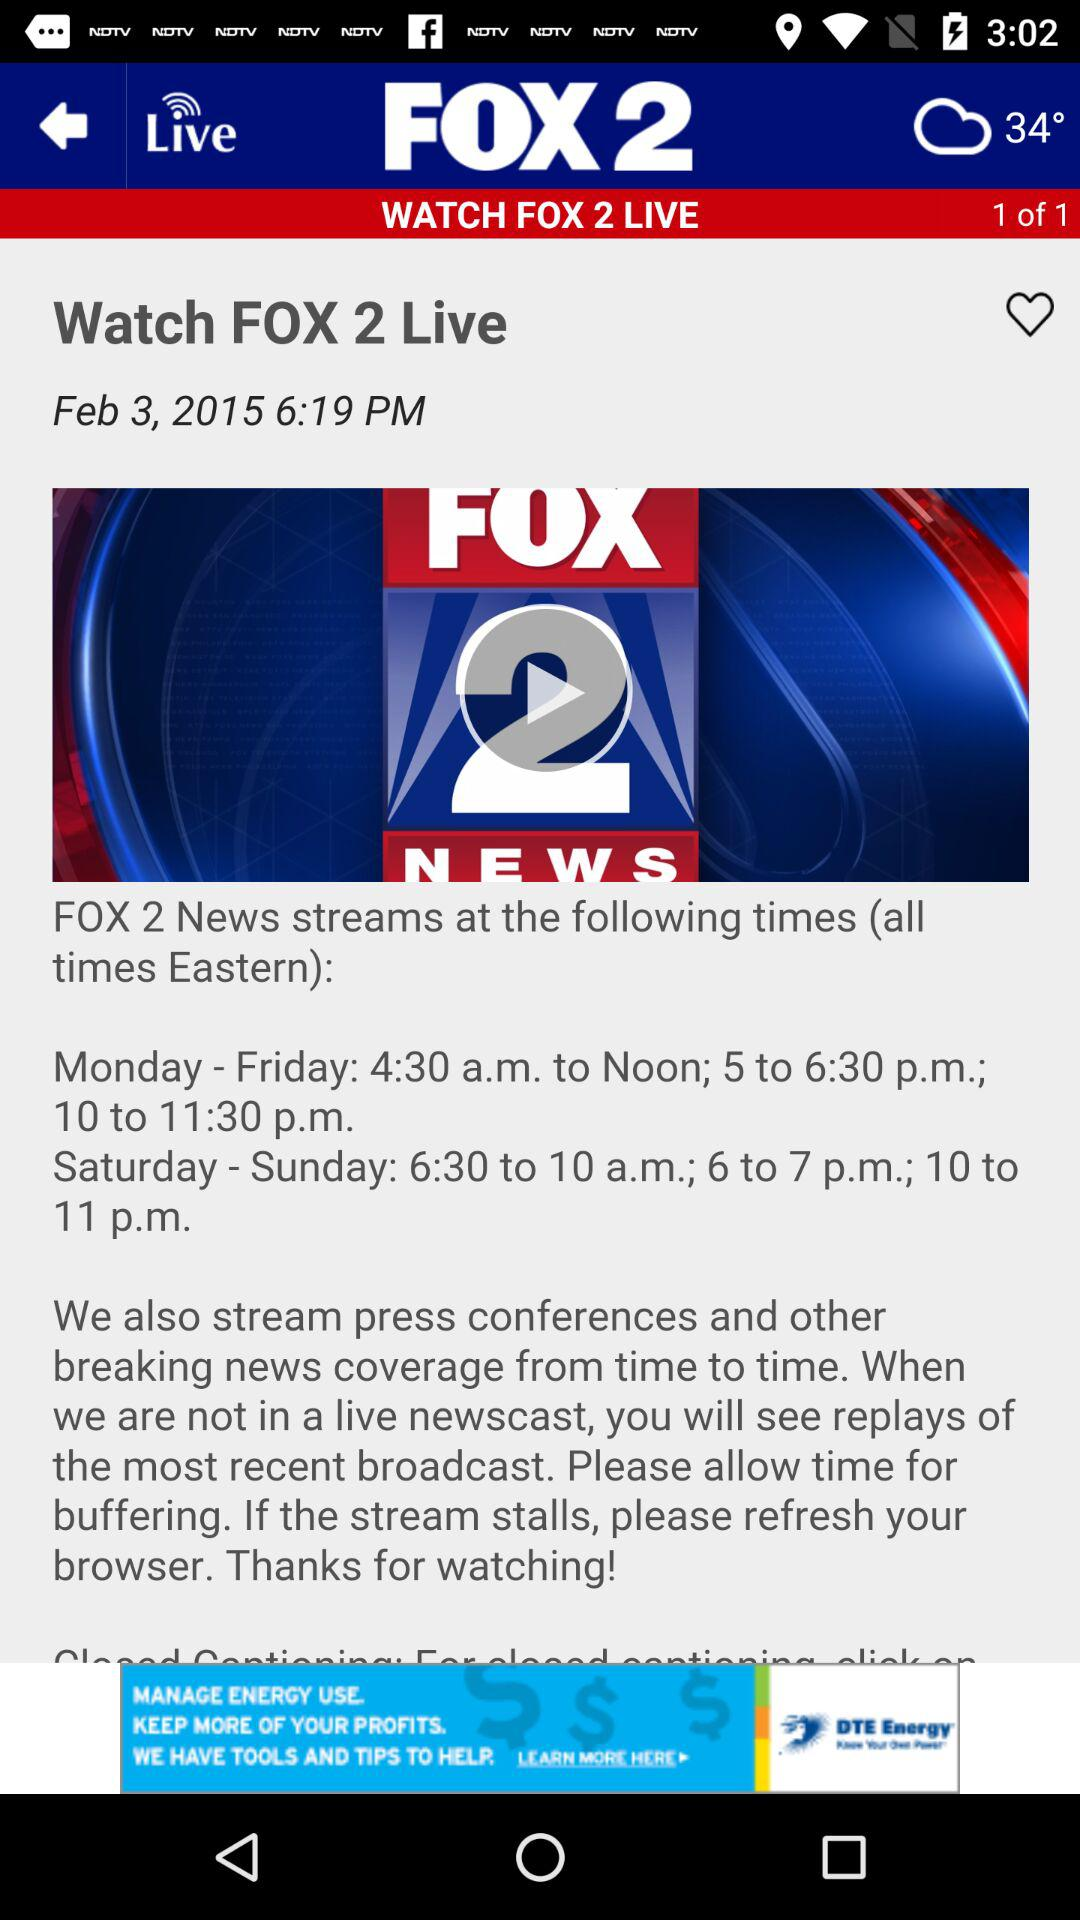How many comments are on the article?
When the provided information is insufficient, respond with <no answer>. <no answer> 